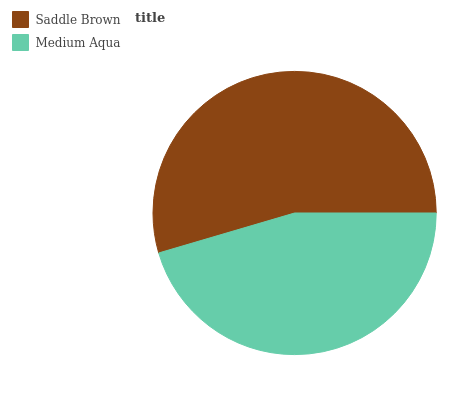Is Medium Aqua the minimum?
Answer yes or no. Yes. Is Saddle Brown the maximum?
Answer yes or no. Yes. Is Medium Aqua the maximum?
Answer yes or no. No. Is Saddle Brown greater than Medium Aqua?
Answer yes or no. Yes. Is Medium Aqua less than Saddle Brown?
Answer yes or no. Yes. Is Medium Aqua greater than Saddle Brown?
Answer yes or no. No. Is Saddle Brown less than Medium Aqua?
Answer yes or no. No. Is Saddle Brown the high median?
Answer yes or no. Yes. Is Medium Aqua the low median?
Answer yes or no. Yes. Is Medium Aqua the high median?
Answer yes or no. No. Is Saddle Brown the low median?
Answer yes or no. No. 